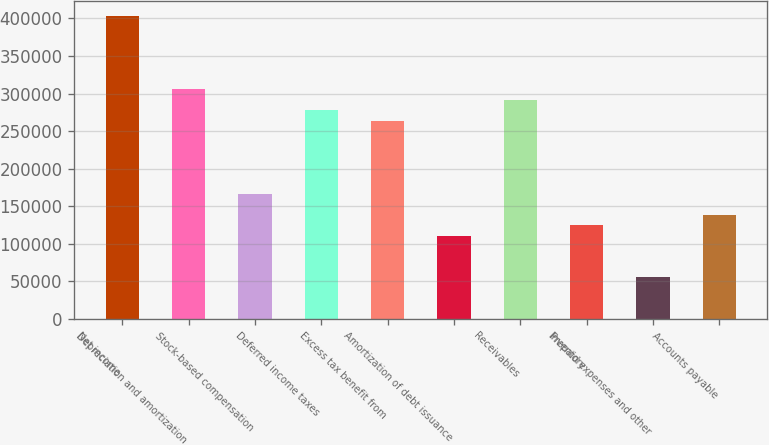Convert chart. <chart><loc_0><loc_0><loc_500><loc_500><bar_chart><fcel>Net income<fcel>Depreciation and amortization<fcel>Stock-based compensation<fcel>Deferred income taxes<fcel>Excess tax benefit from<fcel>Amortization of debt issuance<fcel>Receivables<fcel>Inventory<fcel>Prepaid expenses and other<fcel>Accounts payable<nl><fcel>402624<fcel>305466<fcel>166669<fcel>277707<fcel>263827<fcel>111151<fcel>291587<fcel>125030<fcel>55631.8<fcel>138910<nl></chart> 